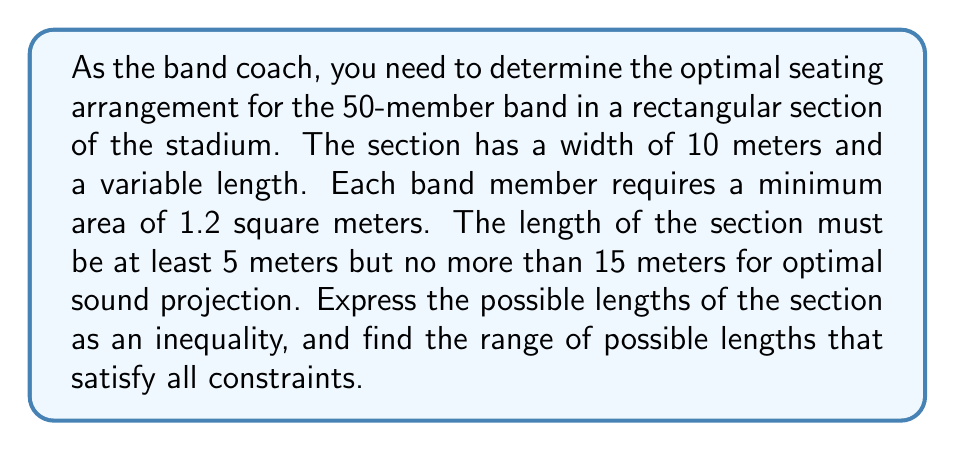Help me with this question. Let's approach this step-by-step:

1) Let $x$ be the length of the section in meters.

2) The area of the section is given by $10x$ square meters (width × length).

3) Each band member needs at least 1.2 square meters, so for 50 members:
   $$10x \geq 50 \times 1.2 = 60$$

4) Simplifying the inequality:
   $$x \geq 6$$

5) We're also given that the length must be at least 5 meters and no more than 15 meters:
   $$5 \leq x \leq 15$$

6) Combining all these constraints:
   $$6 \leq x \leq 15$$

7) Therefore, the possible lengths of the section can be expressed as:
   $$6 \leq x \leq 15$$

8) The range of possible lengths is from 6 meters to 15 meters.
Answer: $6 \leq x \leq 15$, where $x$ is the length in meters 